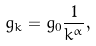Convert formula to latex. <formula><loc_0><loc_0><loc_500><loc_500>g _ { k } = g _ { 0 } \frac { 1 } { k ^ { \alpha } } ,</formula> 